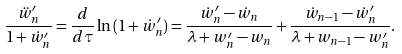Convert formula to latex. <formula><loc_0><loc_0><loc_500><loc_500>\frac { \ddot { w } _ { n } ^ { \prime } } { 1 + \dot { w } _ { n } ^ { \prime } } = \frac { d } { d \tau } \ln { ( 1 + \dot { w } _ { n } ^ { \prime } ) } = \frac { \dot { w } _ { n } ^ { \prime } - \dot { w } _ { n } } { \lambda + w _ { n } ^ { \prime } - w _ { n } } + \frac { \dot { w } _ { n - 1 } - \dot { w } _ { n } ^ { \prime } } { \lambda + w _ { n - 1 } - w _ { n } ^ { \prime } } .</formula> 